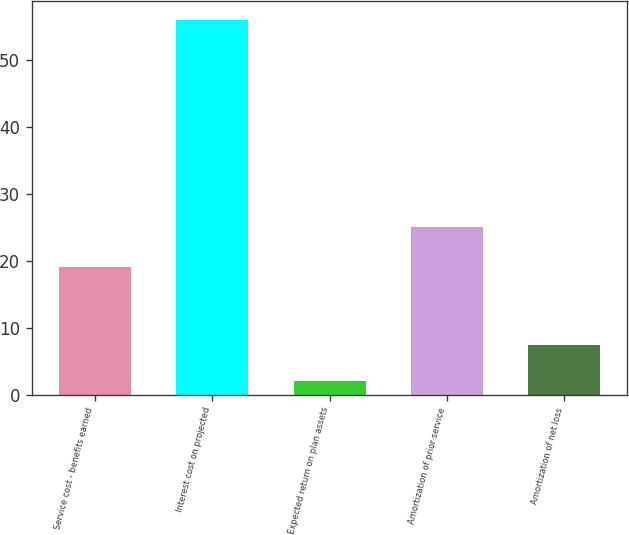Convert chart. <chart><loc_0><loc_0><loc_500><loc_500><bar_chart><fcel>Service cost - benefits earned<fcel>Interest cost on projected<fcel>Expected return on plan assets<fcel>Amortization of prior service<fcel>Amortization of net loss<nl><fcel>19<fcel>56<fcel>2<fcel>25<fcel>7.4<nl></chart> 